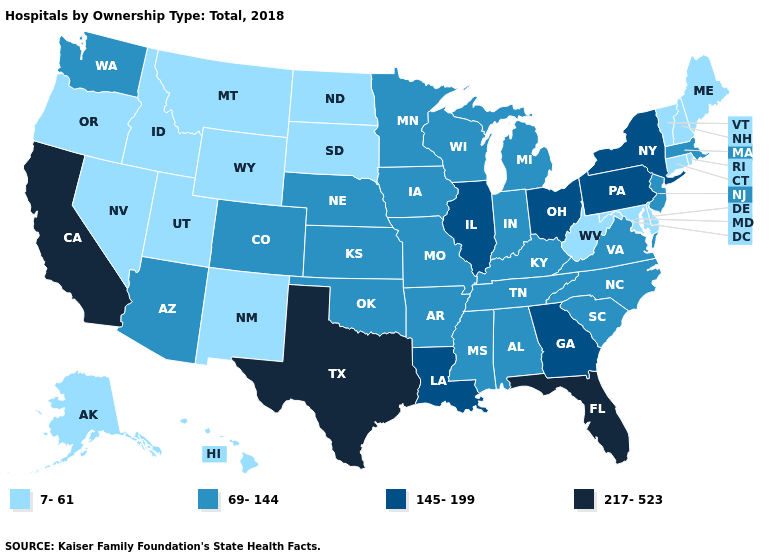Does Oklahoma have a higher value than Idaho?
Quick response, please. Yes. What is the value of Nebraska?
Concise answer only. 69-144. Name the states that have a value in the range 7-61?
Quick response, please. Alaska, Connecticut, Delaware, Hawaii, Idaho, Maine, Maryland, Montana, Nevada, New Hampshire, New Mexico, North Dakota, Oregon, Rhode Island, South Dakota, Utah, Vermont, West Virginia, Wyoming. Does the map have missing data?
Write a very short answer. No. Which states have the highest value in the USA?
Write a very short answer. California, Florida, Texas. Which states hav the highest value in the Northeast?
Answer briefly. New York, Pennsylvania. What is the value of Wisconsin?
Answer briefly. 69-144. What is the lowest value in states that border Tennessee?
Write a very short answer. 69-144. Does Massachusetts have a lower value than Louisiana?
Answer briefly. Yes. Name the states that have a value in the range 145-199?
Answer briefly. Georgia, Illinois, Louisiana, New York, Ohio, Pennsylvania. Does Wisconsin have the lowest value in the USA?
Concise answer only. No. Does the map have missing data?
Write a very short answer. No. Name the states that have a value in the range 69-144?
Be succinct. Alabama, Arizona, Arkansas, Colorado, Indiana, Iowa, Kansas, Kentucky, Massachusetts, Michigan, Minnesota, Mississippi, Missouri, Nebraska, New Jersey, North Carolina, Oklahoma, South Carolina, Tennessee, Virginia, Washington, Wisconsin. What is the value of Kansas?
Answer briefly. 69-144. What is the lowest value in the MidWest?
Answer briefly. 7-61. 